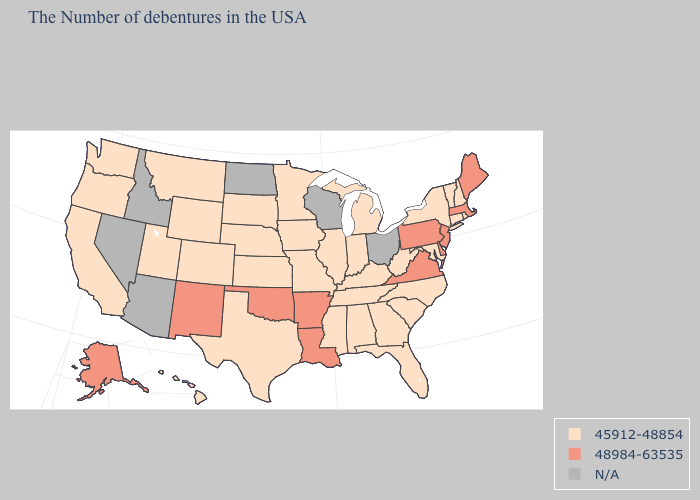Name the states that have a value in the range N/A?
Keep it brief. Ohio, Wisconsin, North Dakota, Arizona, Idaho, Nevada. What is the value of Connecticut?
Concise answer only. 45912-48854. What is the lowest value in the West?
Answer briefly. 45912-48854. What is the lowest value in the West?
Keep it brief. 45912-48854. Name the states that have a value in the range 45912-48854?
Keep it brief. Rhode Island, New Hampshire, Vermont, Connecticut, New York, Maryland, North Carolina, South Carolina, West Virginia, Florida, Georgia, Michigan, Kentucky, Indiana, Alabama, Tennessee, Illinois, Mississippi, Missouri, Minnesota, Iowa, Kansas, Nebraska, Texas, South Dakota, Wyoming, Colorado, Utah, Montana, California, Washington, Oregon, Hawaii. What is the highest value in the MidWest ?
Quick response, please. 45912-48854. What is the value of New Hampshire?
Be succinct. 45912-48854. Which states have the lowest value in the West?
Write a very short answer. Wyoming, Colorado, Utah, Montana, California, Washington, Oregon, Hawaii. Name the states that have a value in the range N/A?
Write a very short answer. Ohio, Wisconsin, North Dakota, Arizona, Idaho, Nevada. Does Pennsylvania have the lowest value in the USA?
Concise answer only. No. What is the lowest value in the USA?
Quick response, please. 45912-48854. What is the highest value in the USA?
Be succinct. 48984-63535. Name the states that have a value in the range N/A?
Keep it brief. Ohio, Wisconsin, North Dakota, Arizona, Idaho, Nevada. 